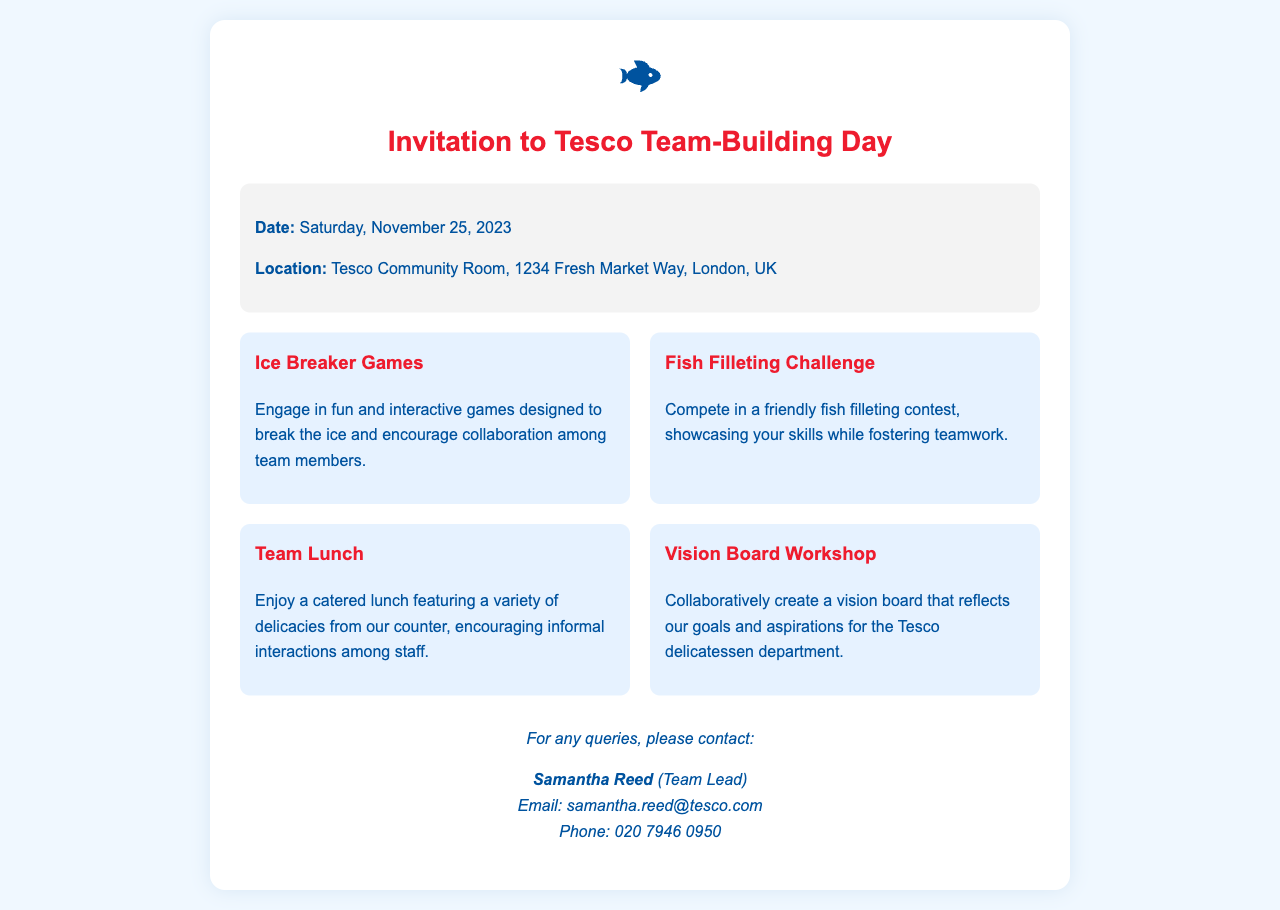What is the date of the team-building event? The date of the event is clearly stated in the document as Saturday, November 25, 2023.
Answer: Saturday, November 25, 2023 Where is the event taking place? The location of the event is specified as Tesco Community Room, 1234 Fresh Market Way, London, UK.
Answer: Tesco Community Room, 1234 Fresh Market Way, London, UK What type of challenge will participants engage in? One of the planned activities is a fish filleting contest, as mentioned in the document.
Answer: Fish Filleting Challenge Who should be contacted for queries? The document lists Samantha Reed as the contact person for any queries related to the event.
Answer: Samantha Reed What activity encourages informal interactions among staff? The team lunch is specifically mentioned as facilitating informal interactions among staff.
Answer: Team Lunch How many activities are planned for the event? The document lists a total of four different activities for the team-building event.
Answer: Four What is the email address provided for queries? The email address for queries is provided as samantha.reed@tesco.com.
Answer: samantha.reed@tesco.com What kind of workshop is included in the activities? A Vision Board Workshop is one of the activities described in the document.
Answer: Vision Board Workshop 